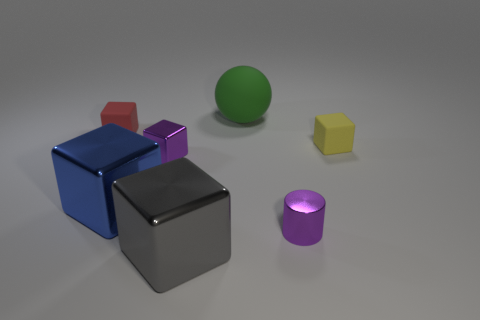Is there anything unique about the lighting in the scene? The lighting in the scene is quite soft and diffused, casting gentle shadows and giving off a calm, studio-like atmosphere. There is no harsh light or strong directional shadows, which suggests an even and well-planned lighting setup, likely intended to showcase the objects without creating distracting contrasts. 